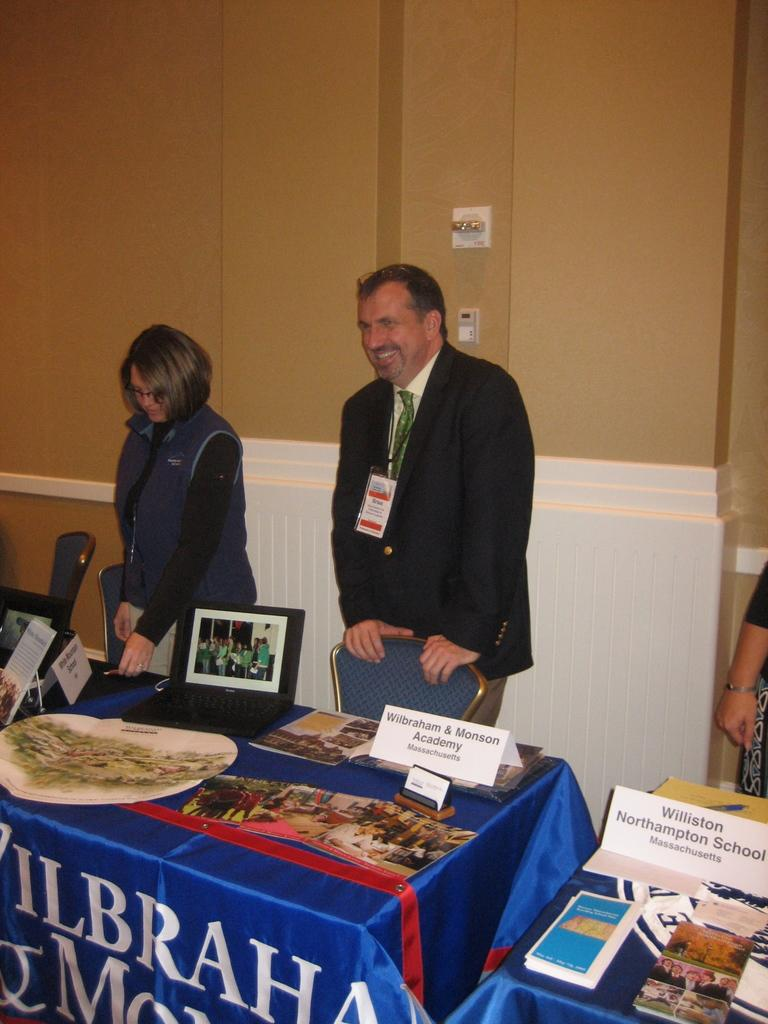<image>
Render a clear and concise summary of the photo. A man stands behind a chair representing Wilbraham and Monson Academy. 